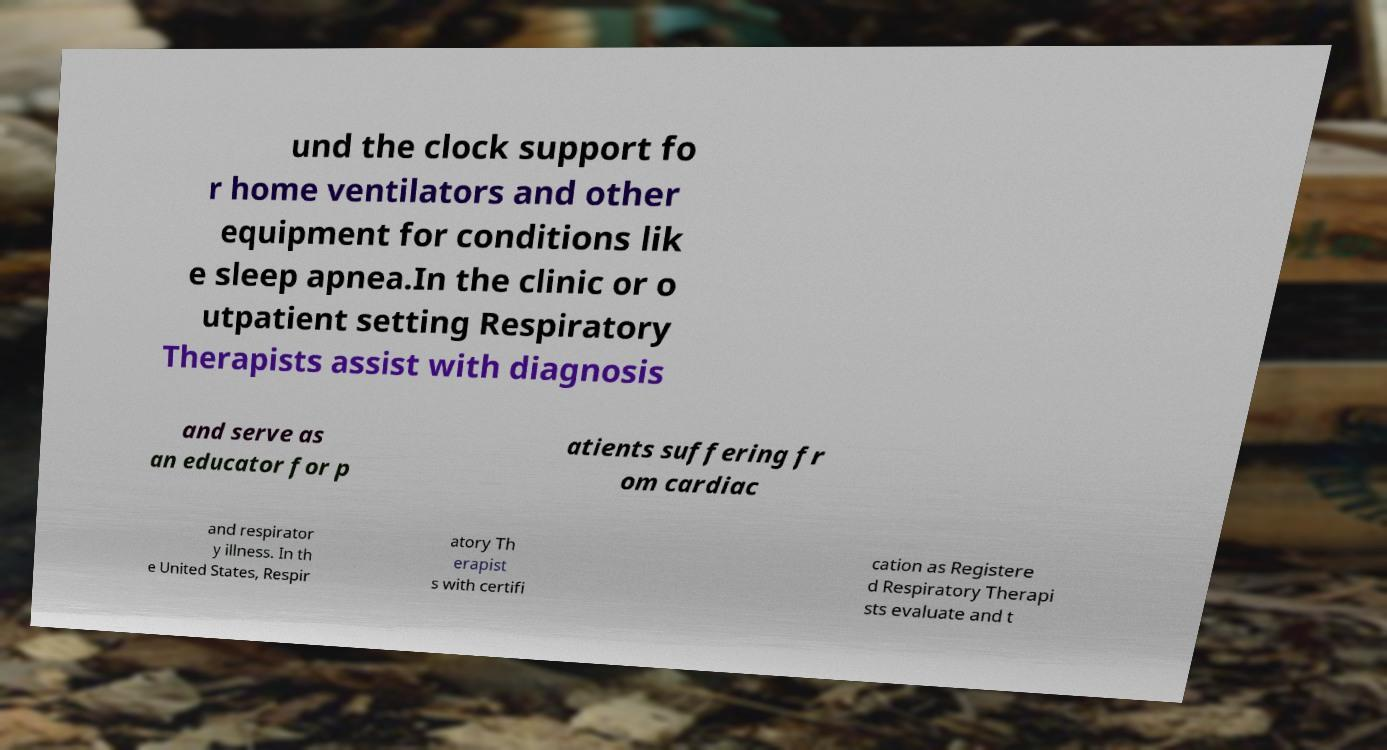I need the written content from this picture converted into text. Can you do that? und the clock support fo r home ventilators and other equipment for conditions lik e sleep apnea.In the clinic or o utpatient setting Respiratory Therapists assist with diagnosis and serve as an educator for p atients suffering fr om cardiac and respirator y illness. In th e United States, Respir atory Th erapist s with certifi cation as Registere d Respiratory Therapi sts evaluate and t 